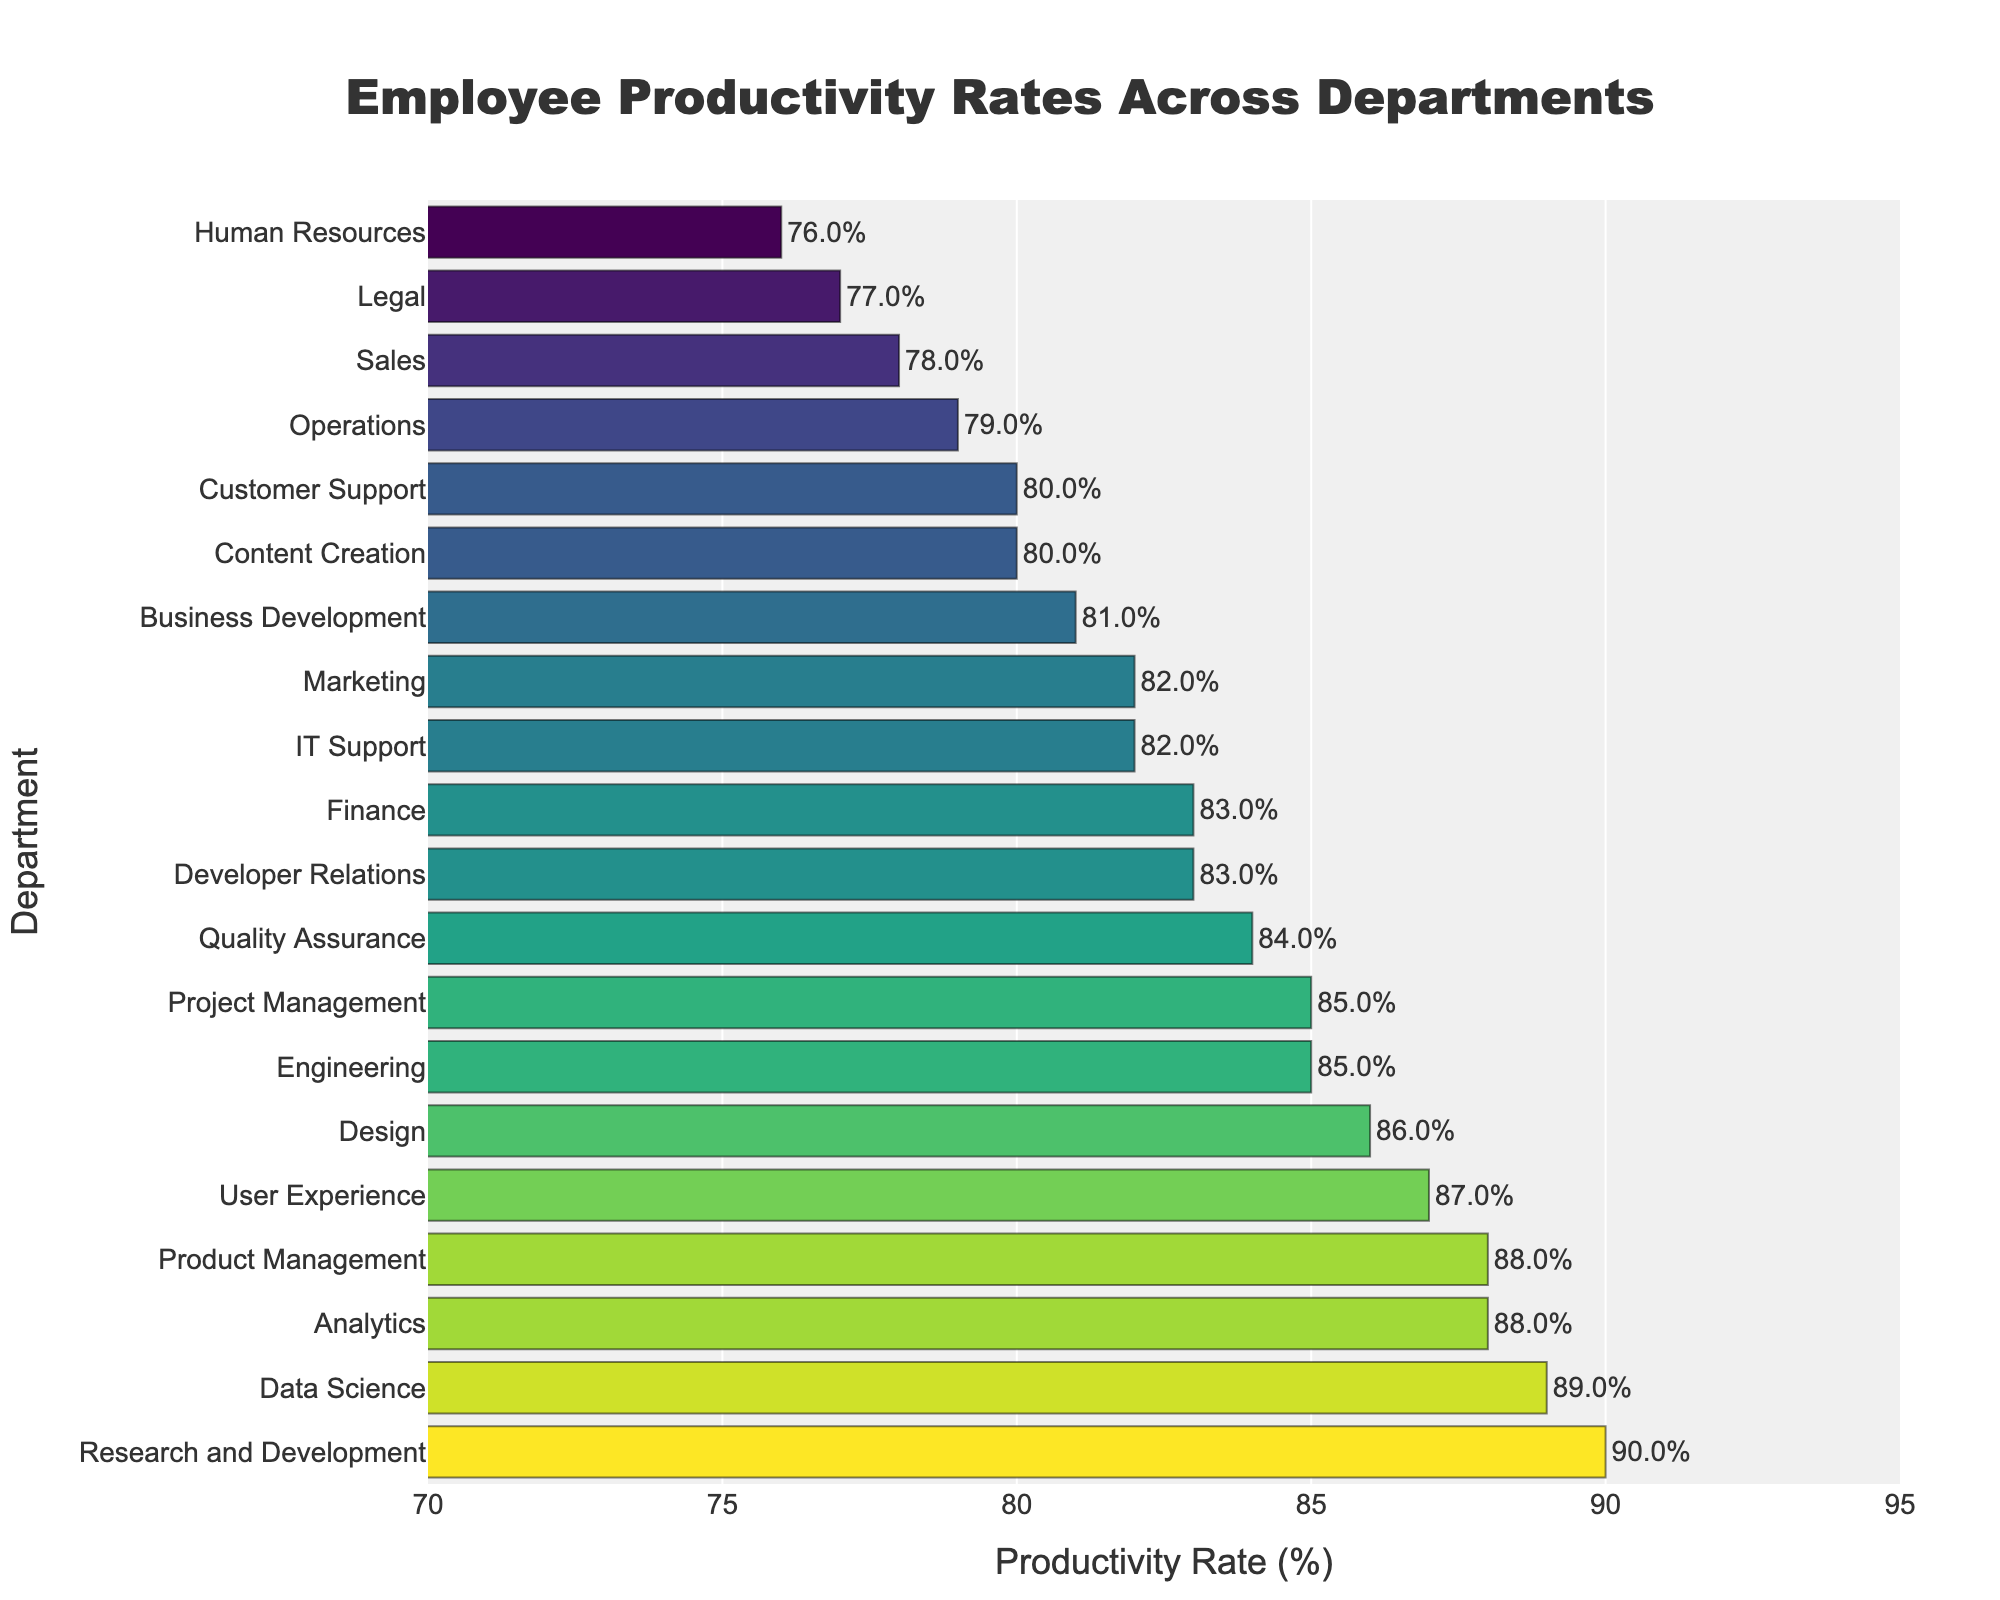Which department has the highest productivity rate? The Research and Development department is shown with the highest bar in the plot, indicating the highest productivity rate.
Answer: Research and Development What is the difference in productivity rate between the Legal and Data Science departments? The productivity rate for the Legal department is 77%, and for Data Science, it is 89%. The difference is calculated as 89% - 77% = 12%.
Answer: 12% How many departments have a productivity rate of 85% or higher? By counting the bars from 85% and above, we can see that the departments are Research and Development (90%), Data Science (89%), Product Management (88%), User Experience (87%), Design (86%), Engineering (85%), and Project Management (85%). This totals to 7 departments.
Answer: 7 Which department has the lowest productivity rate? The bar for Human Resources is the shortest, indicating the lowest productivity rate at 76%.
Answer: Human Resources Arrange the top three departments by productivity rate. The top three departments by height are Research and Development (90%), Data Science (89%), and Product Management & Analytics (both at 88%).
Answer: Research and Development, Data Science, Product Management & Analytics What's the average productivity rate of all departments? To find the average, sum all productivity rates (85+78+82+80+88+76+83+90+79+84+81+86+77+89+82+80+85+87+88+83) = 1591, then divide by the number of departments (20). The average productivity rate is 1591 / 20 = 79.55%.
Answer: 79.55% Which department's productivity rate is closest to the overall average productivity rate? The average productivity rate is 79.55%. The departments closest to this figure are Operations (79%) and Sales (78%), but Operations at 79% is closer to the average.
Answer: Operations Is the productivity rate of the Quality Assurance department higher than that of the Engineering department? The productivity rate for Quality Assurance is 84%, while the rate for Engineering is 85%. Since 84% is less than 85%, the productivity rate of Quality Assurance is not higher.
Answer: No What is the range of productivity rates among all departments? The highest productivity rate is 90% (Research and Development), and the lowest is 76% (Human Resources). The range is calculated as 90% - 76% = 14%.
Answer: 14% Which department's productivity rate is directly between Customer Support and Sales? The productivity rate for Customer Support is 80%, and for Sales is 78%. The department with a productivity rate between these two is Operations at 79%.
Answer: Operations 